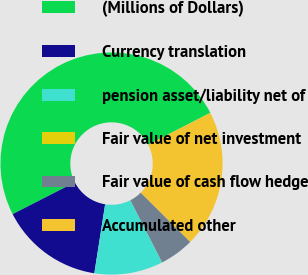Convert chart. <chart><loc_0><loc_0><loc_500><loc_500><pie_chart><fcel>(Millions of Dollars)<fcel>Currency translation<fcel>pension asset/liability net of<fcel>Fair value of net investment<fcel>Fair value of cash flow hedge<fcel>Accumulated other<nl><fcel>49.98%<fcel>15.0%<fcel>10.0%<fcel>0.01%<fcel>5.01%<fcel>20.0%<nl></chart> 